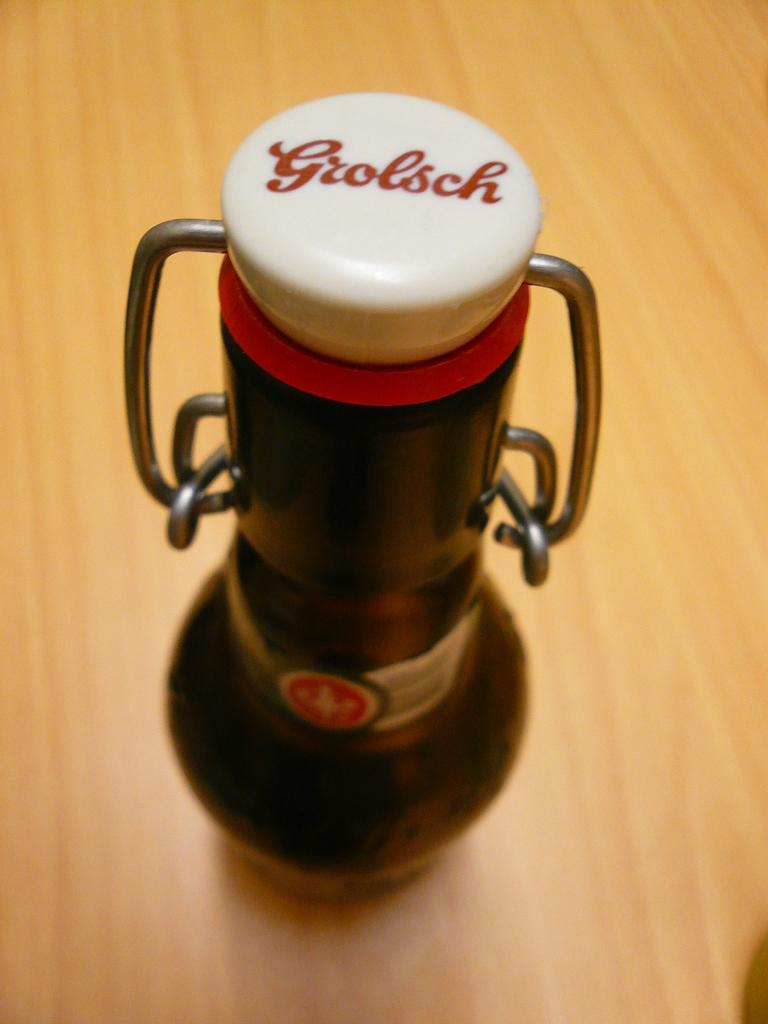<image>
Create a compact narrative representing the image presented. The bottle of Grolsch beer has a ceramic top attached with a metal hinge. 